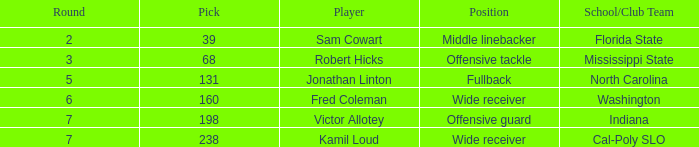Which school/club team holds a choice of 198? Indiana. 